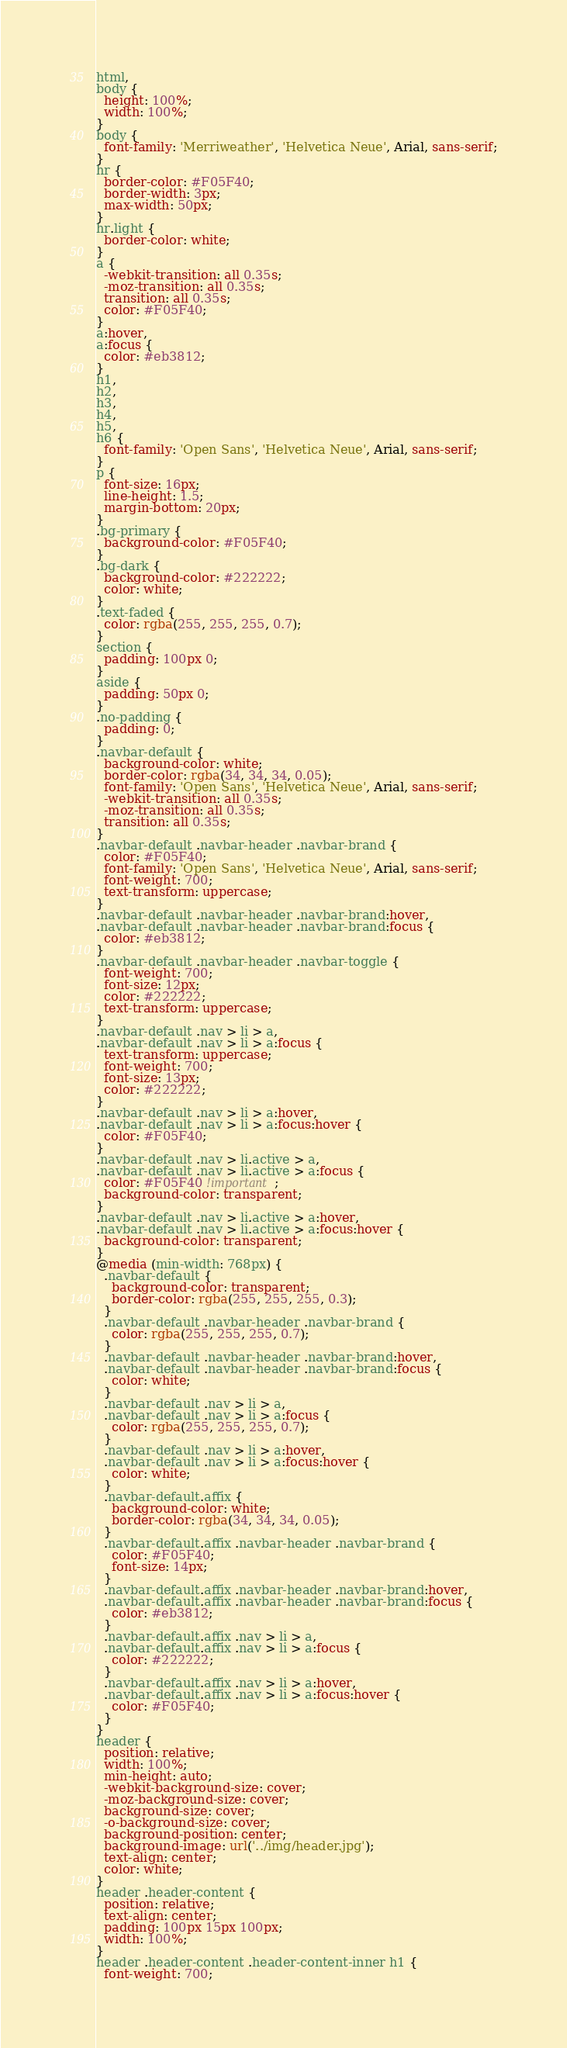Convert code to text. <code><loc_0><loc_0><loc_500><loc_500><_CSS_>html,
body {
  height: 100%;
  width: 100%;
}
body {
  font-family: 'Merriweather', 'Helvetica Neue', Arial, sans-serif;
}
hr {
  border-color: #F05F40;
  border-width: 3px;
  max-width: 50px;
}
hr.light {
  border-color: white;
}
a {
  -webkit-transition: all 0.35s;
  -moz-transition: all 0.35s;
  transition: all 0.35s;
  color: #F05F40;
}
a:hover,
a:focus {
  color: #eb3812;
}
h1,
h2,
h3,
h4,
h5,
h6 {
  font-family: 'Open Sans', 'Helvetica Neue', Arial, sans-serif;
}
p {
  font-size: 16px;
  line-height: 1.5;
  margin-bottom: 20px;
}
.bg-primary {
  background-color: #F05F40;
}
.bg-dark {
  background-color: #222222;
  color: white;
}
.text-faded {
  color: rgba(255, 255, 255, 0.7);
}
section {
  padding: 100px 0;
}
aside {
  padding: 50px 0;
}
.no-padding {
  padding: 0;
}
.navbar-default {
  background-color: white;
  border-color: rgba(34, 34, 34, 0.05);
  font-family: 'Open Sans', 'Helvetica Neue', Arial, sans-serif;
  -webkit-transition: all 0.35s;
  -moz-transition: all 0.35s;
  transition: all 0.35s;
}
.navbar-default .navbar-header .navbar-brand {
  color: #F05F40;
  font-family: 'Open Sans', 'Helvetica Neue', Arial, sans-serif;
  font-weight: 700;
  text-transform: uppercase;
}
.navbar-default .navbar-header .navbar-brand:hover,
.navbar-default .navbar-header .navbar-brand:focus {
  color: #eb3812;
}
.navbar-default .navbar-header .navbar-toggle {
  font-weight: 700;
  font-size: 12px;
  color: #222222;
  text-transform: uppercase;
}
.navbar-default .nav > li > a,
.navbar-default .nav > li > a:focus {
  text-transform: uppercase;
  font-weight: 700;
  font-size: 13px;
  color: #222222;
}
.navbar-default .nav > li > a:hover,
.navbar-default .nav > li > a:focus:hover {
  color: #F05F40;
}
.navbar-default .nav > li.active > a,
.navbar-default .nav > li.active > a:focus {
  color: #F05F40 !important;
  background-color: transparent;
}
.navbar-default .nav > li.active > a:hover,
.navbar-default .nav > li.active > a:focus:hover {
  background-color: transparent;
}
@media (min-width: 768px) {
  .navbar-default {
    background-color: transparent;
    border-color: rgba(255, 255, 255, 0.3);
  }
  .navbar-default .navbar-header .navbar-brand {
    color: rgba(255, 255, 255, 0.7);
  }
  .navbar-default .navbar-header .navbar-brand:hover,
  .navbar-default .navbar-header .navbar-brand:focus {
    color: white;
  }
  .navbar-default .nav > li > a,
  .navbar-default .nav > li > a:focus {
    color: rgba(255, 255, 255, 0.7);
  }
  .navbar-default .nav > li > a:hover,
  .navbar-default .nav > li > a:focus:hover {
    color: white;
  }
  .navbar-default.affix {
    background-color: white;
    border-color: rgba(34, 34, 34, 0.05);
  }
  .navbar-default.affix .navbar-header .navbar-brand {
    color: #F05F40;
    font-size: 14px;
  }
  .navbar-default.affix .navbar-header .navbar-brand:hover,
  .navbar-default.affix .navbar-header .navbar-brand:focus {
    color: #eb3812;
  }
  .navbar-default.affix .nav > li > a,
  .navbar-default.affix .nav > li > a:focus {
    color: #222222;
  }
  .navbar-default.affix .nav > li > a:hover,
  .navbar-default.affix .nav > li > a:focus:hover {
    color: #F05F40;
  }
}
header {
  position: relative;
  width: 100%;
  min-height: auto;
  -webkit-background-size: cover;
  -moz-background-size: cover;
  background-size: cover;
  -o-background-size: cover;
  background-position: center;
  background-image: url('../img/header.jpg');
  text-align: center;
  color: white;
}
header .header-content {
  position: relative;
  text-align: center;
  padding: 100px 15px 100px;
  width: 100%;
}
header .header-content .header-content-inner h1 {
  font-weight: 700;</code> 